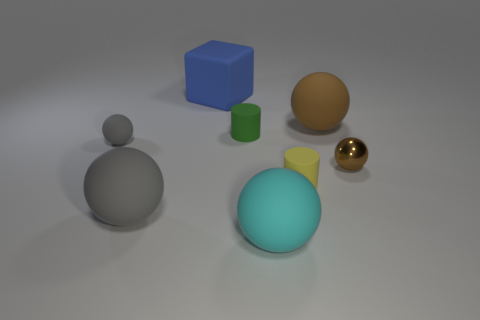Is the number of small green cylinders less than the number of big yellow metallic cubes?
Ensure brevity in your answer.  No. How many matte things are small green cylinders or large gray things?
Your answer should be very brief. 2. There is a object behind the big brown object; are there any tiny yellow things that are to the left of it?
Give a very brief answer. No. Is the material of the large thing on the left side of the blue rubber cube the same as the big brown thing?
Offer a terse response. Yes. How many other things are the same color as the block?
Offer a very short reply. 0. Is the color of the big block the same as the metal ball?
Provide a succinct answer. No. What is the size of the gray matte thing behind the tiny rubber cylinder that is to the right of the cyan rubber thing?
Keep it short and to the point. Small. Does the small ball that is to the left of the big block have the same material as the large ball that is to the right of the big cyan object?
Ensure brevity in your answer.  Yes. Is the color of the big sphere on the left side of the large cyan thing the same as the matte block?
Keep it short and to the point. No. What number of tiny balls are left of the small gray matte ball?
Offer a very short reply. 0. 